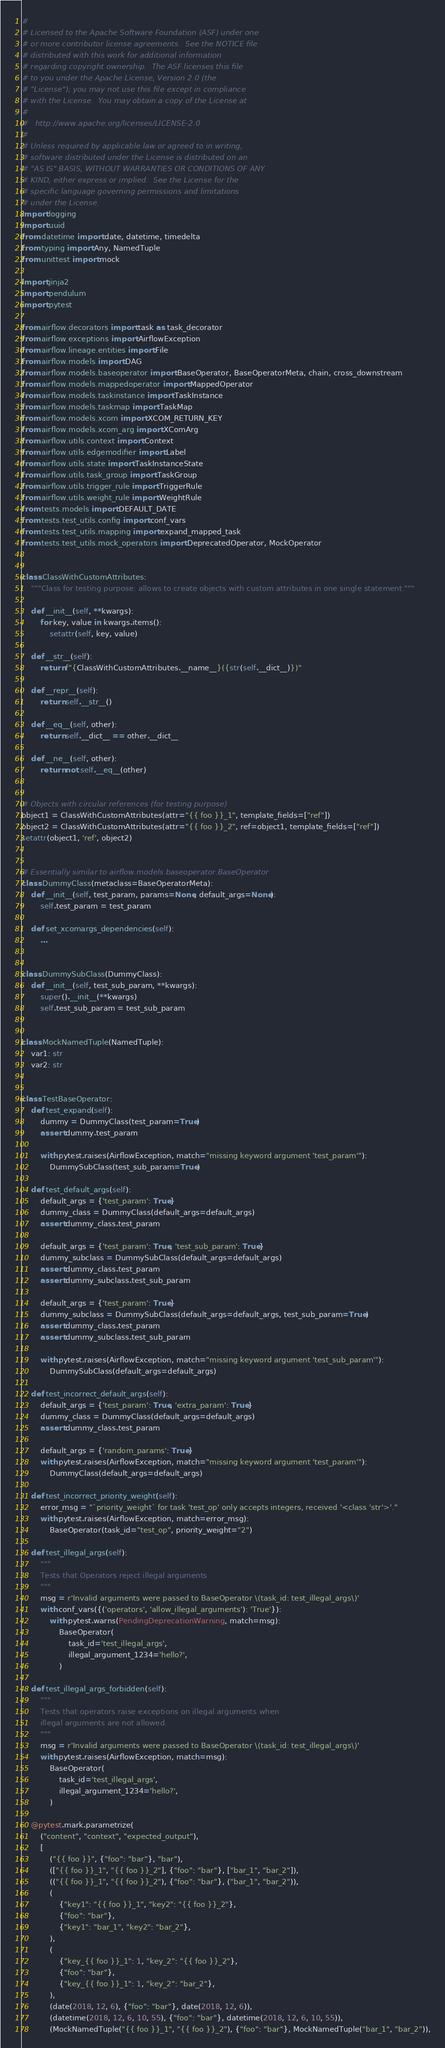Convert code to text. <code><loc_0><loc_0><loc_500><loc_500><_Python_>#
# Licensed to the Apache Software Foundation (ASF) under one
# or more contributor license agreements.  See the NOTICE file
# distributed with this work for additional information
# regarding copyright ownership.  The ASF licenses this file
# to you under the Apache License, Version 2.0 (the
# "License"); you may not use this file except in compliance
# with the License.  You may obtain a copy of the License at
#
#   http://www.apache.org/licenses/LICENSE-2.0
#
# Unless required by applicable law or agreed to in writing,
# software distributed under the License is distributed on an
# "AS IS" BASIS, WITHOUT WARRANTIES OR CONDITIONS OF ANY
# KIND, either express or implied.  See the License for the
# specific language governing permissions and limitations
# under the License.
import logging
import uuid
from datetime import date, datetime, timedelta
from typing import Any, NamedTuple
from unittest import mock

import jinja2
import pendulum
import pytest

from airflow.decorators import task as task_decorator
from airflow.exceptions import AirflowException
from airflow.lineage.entities import File
from airflow.models import DAG
from airflow.models.baseoperator import BaseOperator, BaseOperatorMeta, chain, cross_downstream
from airflow.models.mappedoperator import MappedOperator
from airflow.models.taskinstance import TaskInstance
from airflow.models.taskmap import TaskMap
from airflow.models.xcom import XCOM_RETURN_KEY
from airflow.models.xcom_arg import XComArg
from airflow.utils.context import Context
from airflow.utils.edgemodifier import Label
from airflow.utils.state import TaskInstanceState
from airflow.utils.task_group import TaskGroup
from airflow.utils.trigger_rule import TriggerRule
from airflow.utils.weight_rule import WeightRule
from tests.models import DEFAULT_DATE
from tests.test_utils.config import conf_vars
from tests.test_utils.mapping import expand_mapped_task
from tests.test_utils.mock_operators import DeprecatedOperator, MockOperator


class ClassWithCustomAttributes:
    """Class for testing purpose: allows to create objects with custom attributes in one single statement."""

    def __init__(self, **kwargs):
        for key, value in kwargs.items():
            setattr(self, key, value)

    def __str__(self):
        return f"{ClassWithCustomAttributes.__name__}({str(self.__dict__)})"

    def __repr__(self):
        return self.__str__()

    def __eq__(self, other):
        return self.__dict__ == other.__dict__

    def __ne__(self, other):
        return not self.__eq__(other)


# Objects with circular references (for testing purpose)
object1 = ClassWithCustomAttributes(attr="{{ foo }}_1", template_fields=["ref"])
object2 = ClassWithCustomAttributes(attr="{{ foo }}_2", ref=object1, template_fields=["ref"])
setattr(object1, 'ref', object2)


# Essentially similar to airflow.models.baseoperator.BaseOperator
class DummyClass(metaclass=BaseOperatorMeta):
    def __init__(self, test_param, params=None, default_args=None):
        self.test_param = test_param

    def set_xcomargs_dependencies(self):
        ...


class DummySubClass(DummyClass):
    def __init__(self, test_sub_param, **kwargs):
        super().__init__(**kwargs)
        self.test_sub_param = test_sub_param


class MockNamedTuple(NamedTuple):
    var1: str
    var2: str


class TestBaseOperator:
    def test_expand(self):
        dummy = DummyClass(test_param=True)
        assert dummy.test_param

        with pytest.raises(AirflowException, match="missing keyword argument 'test_param'"):
            DummySubClass(test_sub_param=True)

    def test_default_args(self):
        default_args = {'test_param': True}
        dummy_class = DummyClass(default_args=default_args)
        assert dummy_class.test_param

        default_args = {'test_param': True, 'test_sub_param': True}
        dummy_subclass = DummySubClass(default_args=default_args)
        assert dummy_class.test_param
        assert dummy_subclass.test_sub_param

        default_args = {'test_param': True}
        dummy_subclass = DummySubClass(default_args=default_args, test_sub_param=True)
        assert dummy_class.test_param
        assert dummy_subclass.test_sub_param

        with pytest.raises(AirflowException, match="missing keyword argument 'test_sub_param'"):
            DummySubClass(default_args=default_args)

    def test_incorrect_default_args(self):
        default_args = {'test_param': True, 'extra_param': True}
        dummy_class = DummyClass(default_args=default_args)
        assert dummy_class.test_param

        default_args = {'random_params': True}
        with pytest.raises(AirflowException, match="missing keyword argument 'test_param'"):
            DummyClass(default_args=default_args)

    def test_incorrect_priority_weight(self):
        error_msg = "`priority_weight` for task 'test_op' only accepts integers, received '<class 'str'>'."
        with pytest.raises(AirflowException, match=error_msg):
            BaseOperator(task_id="test_op", priority_weight="2")

    def test_illegal_args(self):
        """
        Tests that Operators reject illegal arguments
        """
        msg = r'Invalid arguments were passed to BaseOperator \(task_id: test_illegal_args\)'
        with conf_vars({('operators', 'allow_illegal_arguments'): 'True'}):
            with pytest.warns(PendingDeprecationWarning, match=msg):
                BaseOperator(
                    task_id='test_illegal_args',
                    illegal_argument_1234='hello?',
                )

    def test_illegal_args_forbidden(self):
        """
        Tests that operators raise exceptions on illegal arguments when
        illegal arguments are not allowed.
        """
        msg = r'Invalid arguments were passed to BaseOperator \(task_id: test_illegal_args\)'
        with pytest.raises(AirflowException, match=msg):
            BaseOperator(
                task_id='test_illegal_args',
                illegal_argument_1234='hello?',
            )

    @pytest.mark.parametrize(
        ("content", "context", "expected_output"),
        [
            ("{{ foo }}", {"foo": "bar"}, "bar"),
            (["{{ foo }}_1", "{{ foo }}_2"], {"foo": "bar"}, ["bar_1", "bar_2"]),
            (("{{ foo }}_1", "{{ foo }}_2"), {"foo": "bar"}, ("bar_1", "bar_2")),
            (
                {"key1": "{{ foo }}_1", "key2": "{{ foo }}_2"},
                {"foo": "bar"},
                {"key1": "bar_1", "key2": "bar_2"},
            ),
            (
                {"key_{{ foo }}_1": 1, "key_2": "{{ foo }}_2"},
                {"foo": "bar"},
                {"key_{{ foo }}_1": 1, "key_2": "bar_2"},
            ),
            (date(2018, 12, 6), {"foo": "bar"}, date(2018, 12, 6)),
            (datetime(2018, 12, 6, 10, 55), {"foo": "bar"}, datetime(2018, 12, 6, 10, 55)),
            (MockNamedTuple("{{ foo }}_1", "{{ foo }}_2"), {"foo": "bar"}, MockNamedTuple("bar_1", "bar_2")),</code> 